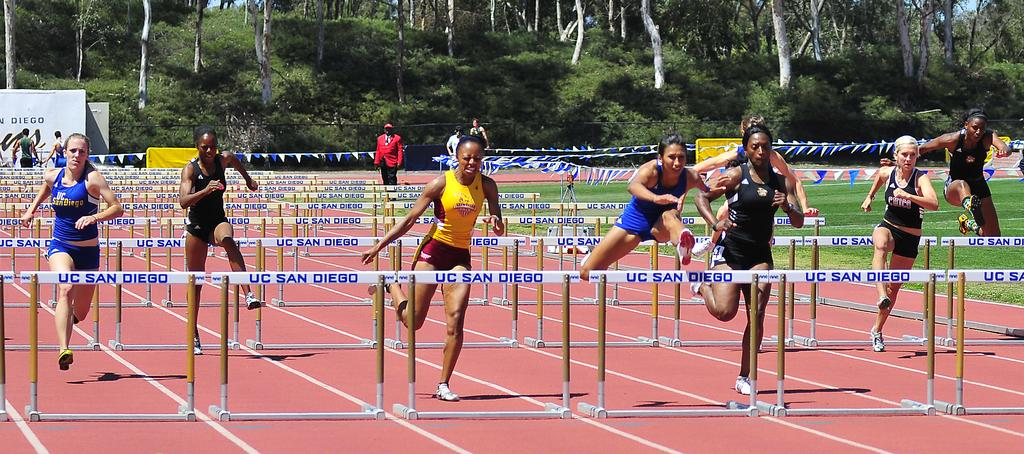<image>
Describe the image concisely. a group of athletes jumping over UC san Diego hurdles 